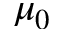<formula> <loc_0><loc_0><loc_500><loc_500>\mu _ { 0 }</formula> 